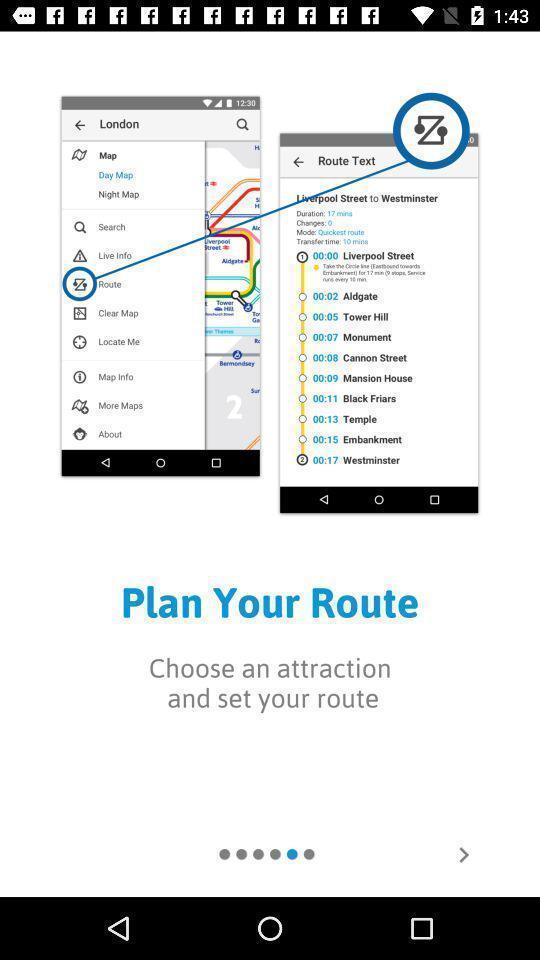Summarize the information in this screenshot. Step in opening a navigation app. 